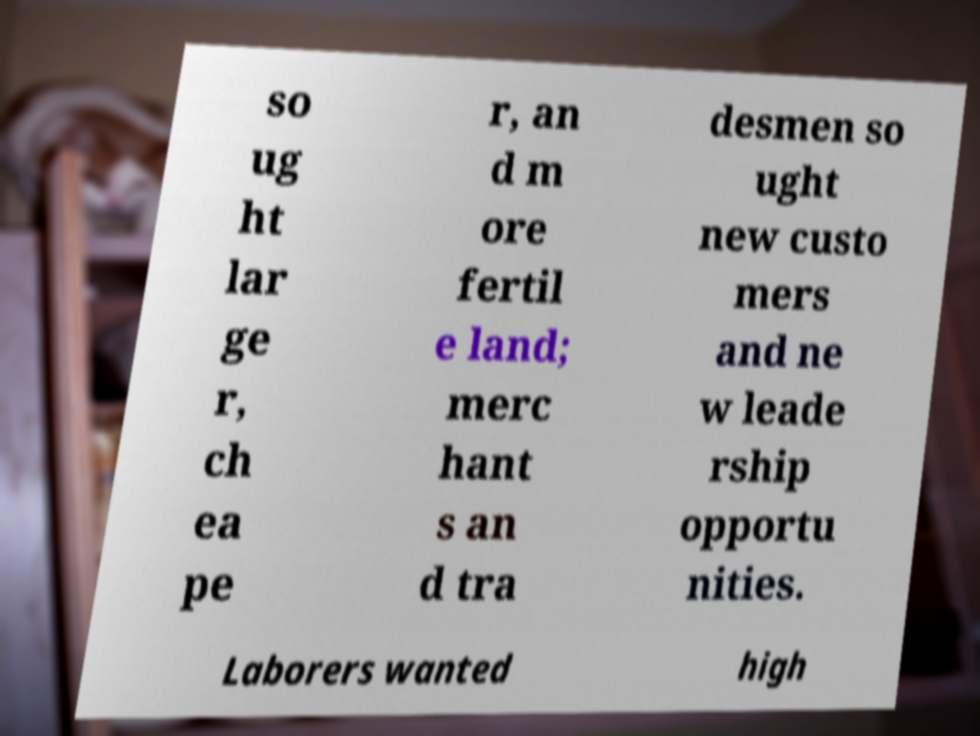For documentation purposes, I need the text within this image transcribed. Could you provide that? so ug ht lar ge r, ch ea pe r, an d m ore fertil e land; merc hant s an d tra desmen so ught new custo mers and ne w leade rship opportu nities. Laborers wanted high 